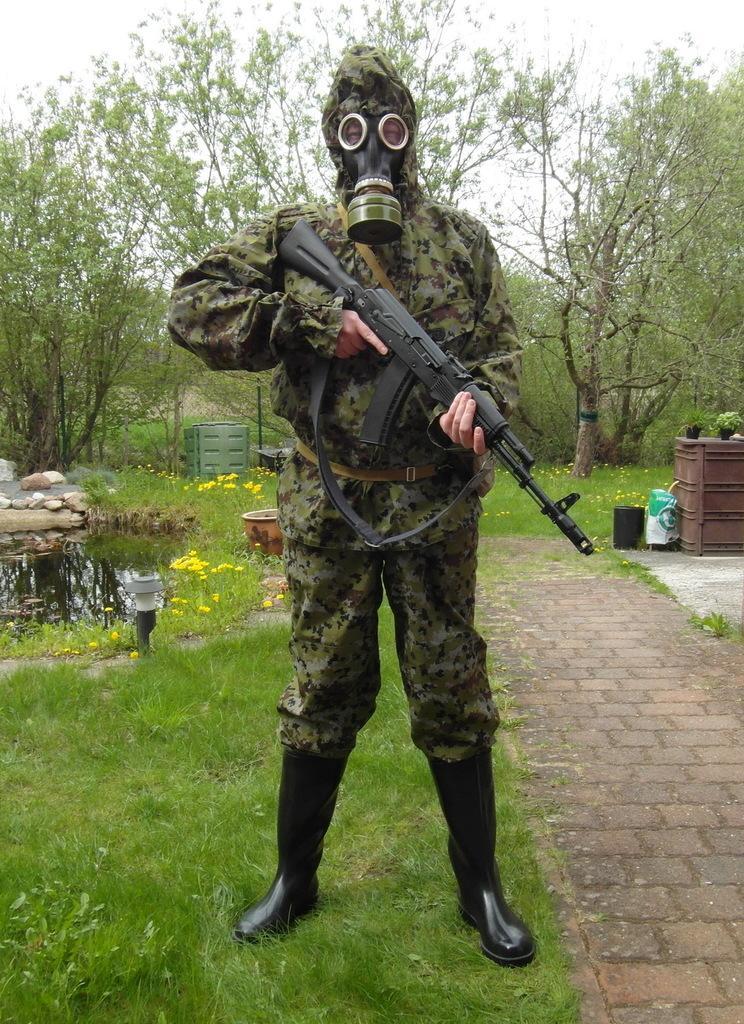In one or two sentences, can you explain what this image depicts? In this image there is a person wearing a face mask is holding a gun in his hand, behind the person there are trees, and there is grass on the surface. 